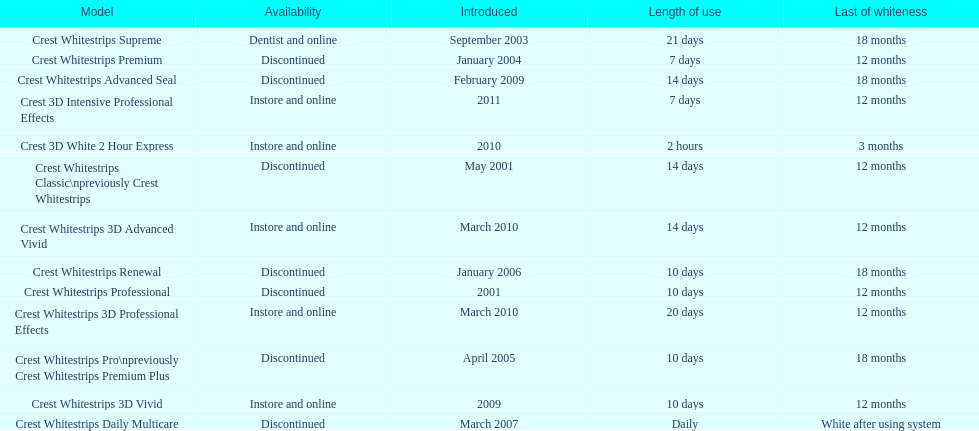Is each white strip discontinued? No. 